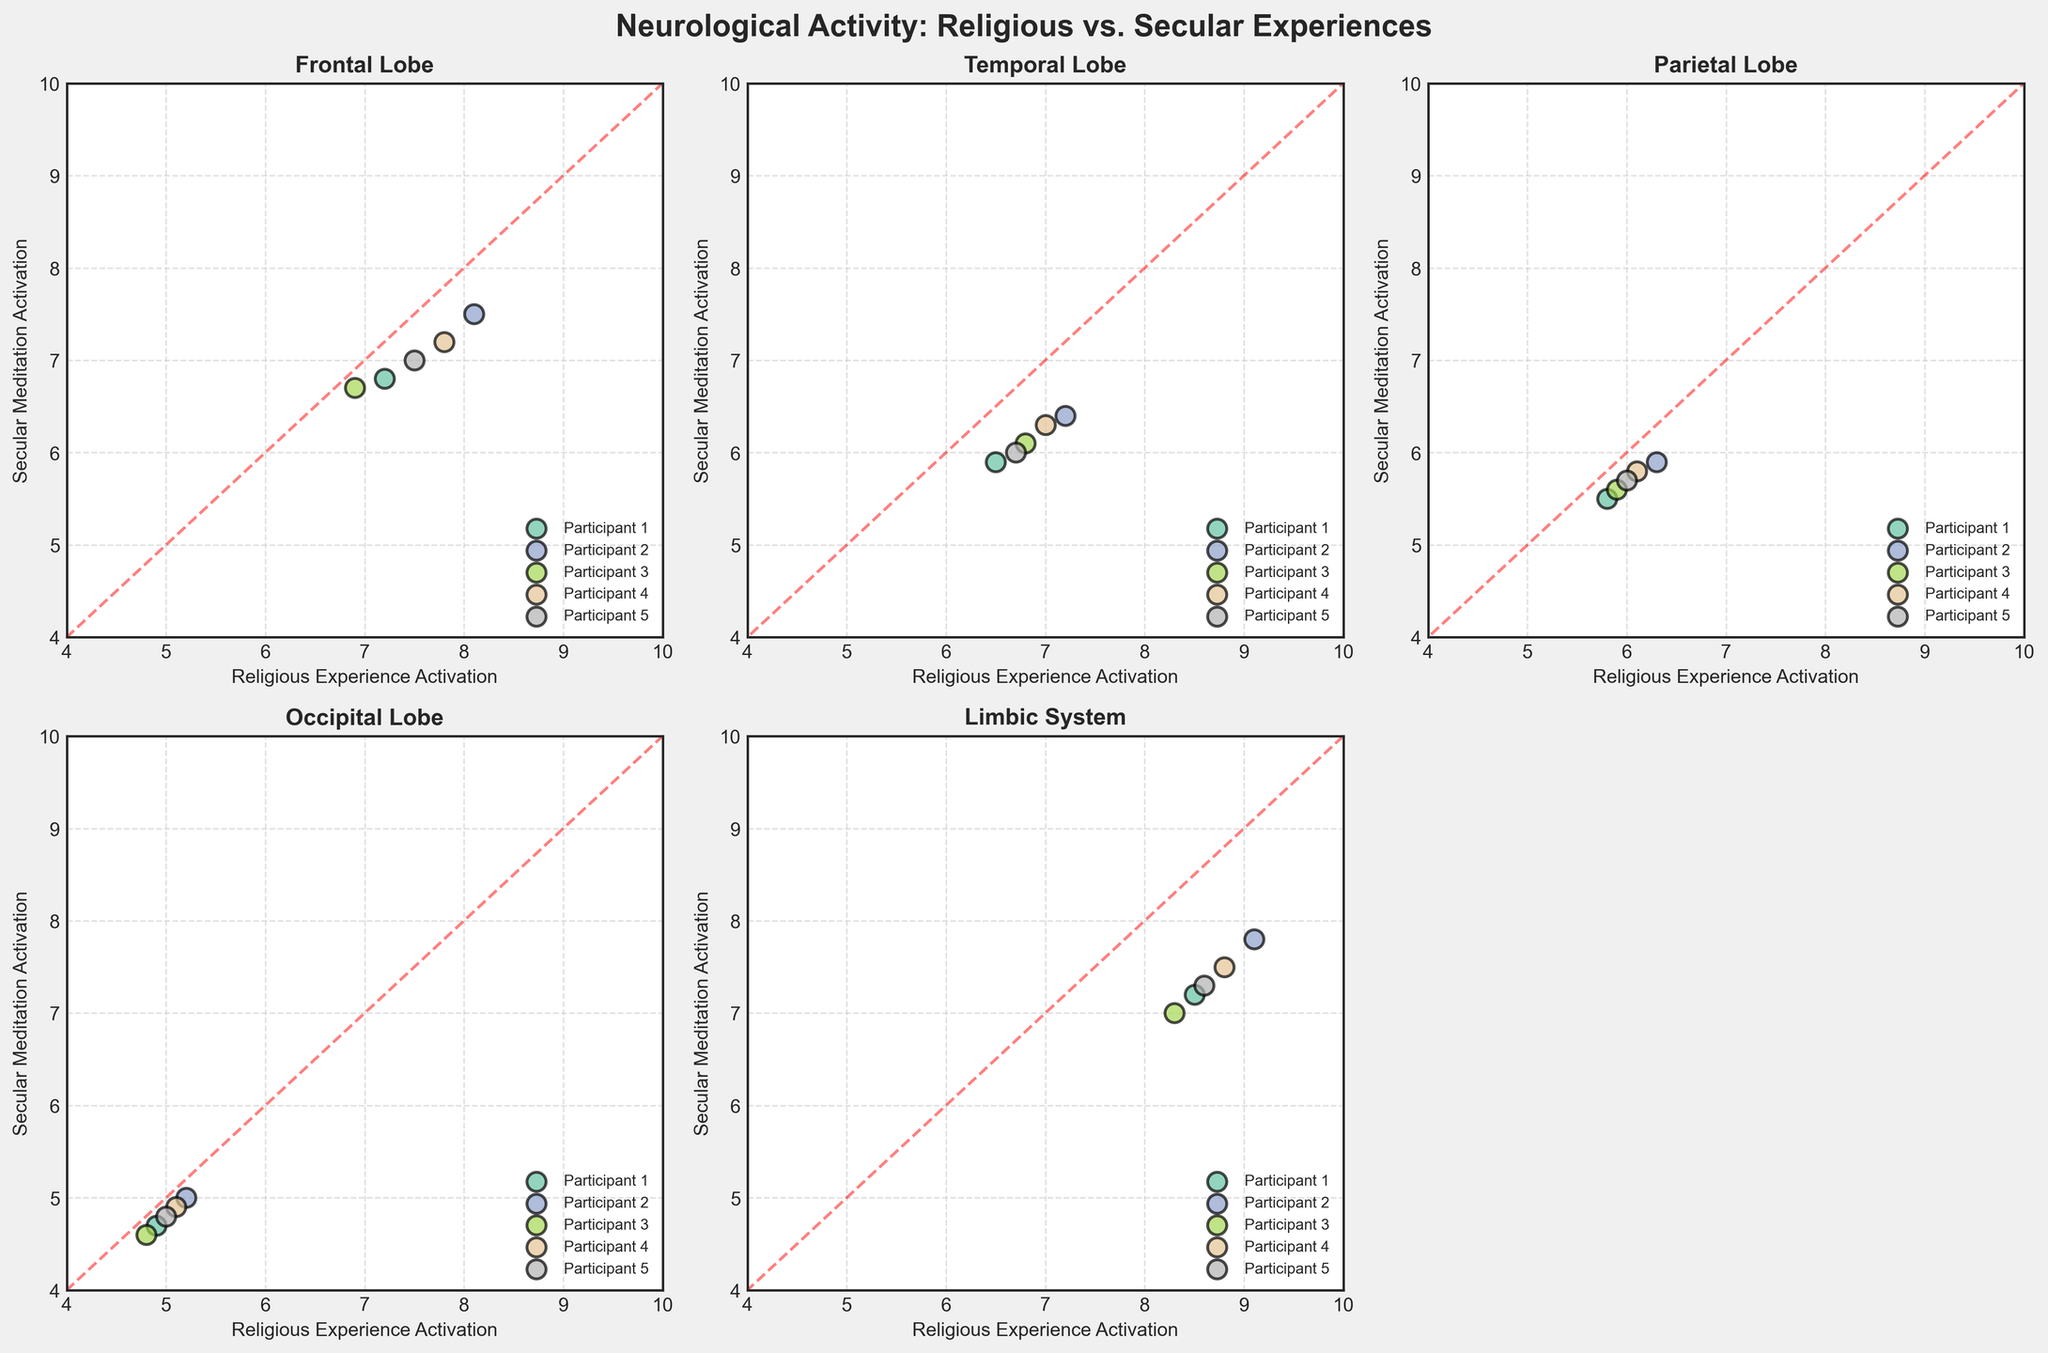what is the highest activation level recorded during secular meditation in the limbic system? Observe the subplot for the limbic system. The highest vertical value (secular meditation activation) indicated by any point in this subplot is 7.8
Answer: 7.8 Which brain region shows the smallest difference between religious experience activation and secular meditation activation for any of the participants? Compare the difference between the activations for each participant in each subplot. The smallest difference noticed visually is for the occipital lobe, where differences are very close, particularly around 0.1
Answer: occipital lobe In which brain region do participants generally show higher activation levels during religious experiences compared to secular meditation? Look at the diagonal red line. Points above this line indicate higher activation during religious experiences. The limbic system subplot shows all points above the red line
Answer: limbic system What is the number of participants with data points near the red dashed line for the parietal lobe? For the parietal lobe subplot, visually count the points close to the diagonal red dashed line within a close range. There are three such points
Answer: 3 Across all brain regions, which participant has the most consistent activation levels between religious experiences and secular meditation? Identify the participant with similar points across all subplots. Participant 3 seems to have consistent values closely aligned with the red dashed line, showcasing similar activation levels
Answer: participant 3 